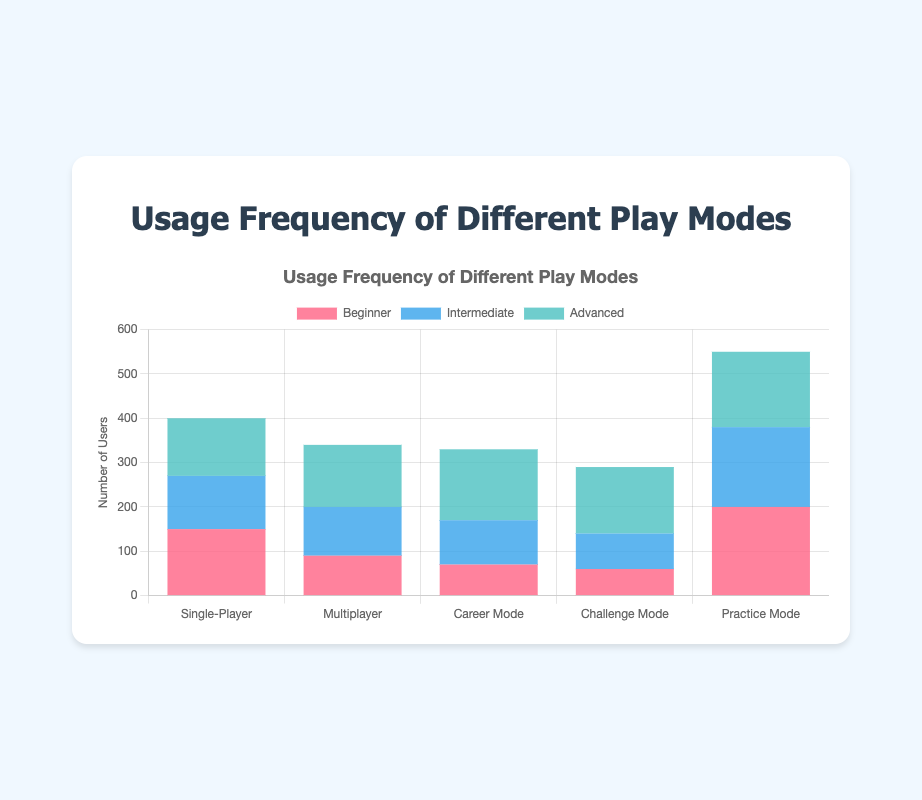Which play mode has the highest number of total users? To determine the play mode with the highest number of users, sum the Beginner, Intermediate, and Advanced users for each play mode. Single-Player: 150 + 120 + 130 = 400, Multiplayer: 90 + 110 + 140 = 340, Career Mode: 70 + 100 + 160 = 330, Challenge Mode: 60 + 80 + 150 = 290, Practice Mode: 200 + 180 + 170 = 550. Practice Mode has the highest number with 550 users
Answer: Practice Mode Which user group (Beginner, Intermediate, Advanced) has the highest usage in Multiplayer mode? Refer to the bars for Multiplayer mode. Beginner: 90, Intermediate: 110, Advanced: 140. Advanced is the highest
Answer: Advanced What is the total number of Beginner users across all play modes? Sum the Beginner users across all play modes: 150 (Single-Player) + 90 (Multiplayer) + 70 (Career Mode) + 60 (Challenge Mode) + 200 (Practice Mode) = 570
Answer: 570 Which play mode is most popular among Intermediate users? Check the heights of the blue bars for Intermediate users. Single-Player: 120, Multiplayer: 110, Career Mode: 100, Challenge Mode: 80, Practice Mode: 180. Practice Mode has the highest usage among Intermediate users
Answer: Practice Mode How does the number of Advanced users in Challenge Mode compare to Single-Player mode? Compare the green bars for Advanced users in each mode. Single-Player: 130, Challenge Mode: 150. Challenge Mode has 20 more Advanced users than Single-Player mode
Answer: Challenge Mode has 20 more users Which play mode has the least number of total users? To find the mode with the fewest users, calculate the total for each: Single-Player: 400, Multiplayer: 340, Career Mode: 330, Challenge Mode: 290, Practice Mode: 550. Challenge Mode has the least number of users with 290
Answer: Challenge Mode Calculate the average number of users for Single-Player mode considering all user groups. Sum the number of users in Single-Player mode and divide by three (for three groups). Total users: 150 (Beginner) + 120 (Intermediate) + 130 (Advanced) = 400. Average: 400 / 3 ≈ 133.33
Answer: 133.33 Which play mode shows the most balanced usage across all user groups? Check the relative heights of the bars within each mode. Single-Player (150, 120, 130) and Career Mode (70, 100, 160) show varying differences. Challenge Mode (60, 80, 150) and Practice Mode (200, 180, 170) also show variability. Multiplayer (90, 110, 140) appears more balanced. The differences in height in Multiplayer are smaller compared to other modes
Answer: Multiplayer 